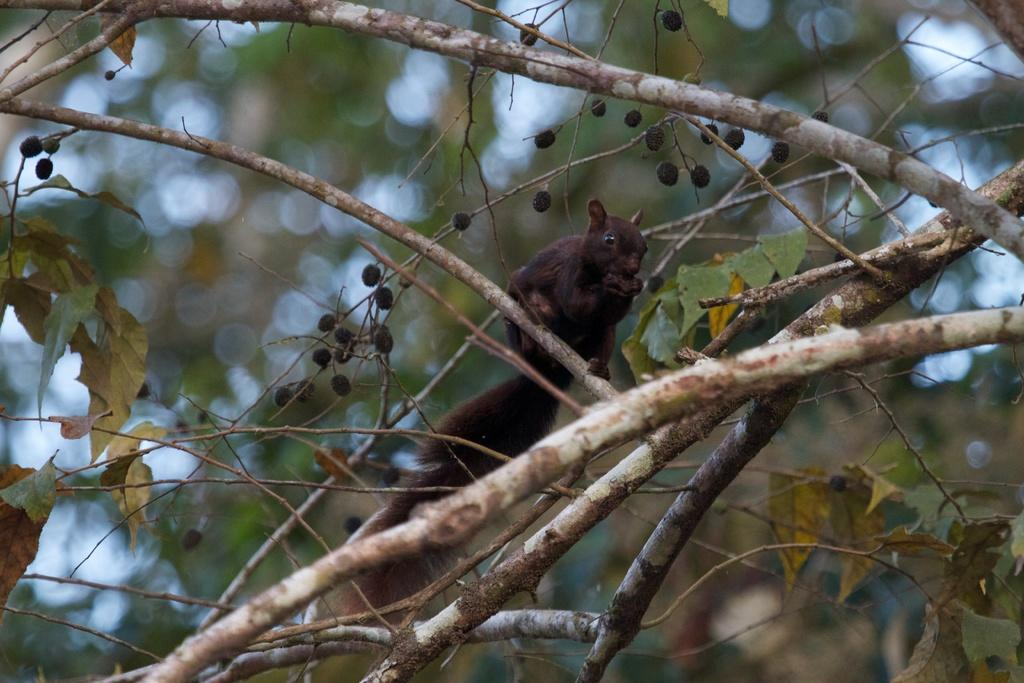What animal can be seen in the image? There is a squirrel in the image. Where is the squirrel located? The squirrel is on a tree branch. What can be seen in the background of the image? There are trees visible in the background of the image. How would you describe the background of the image? The background is blurry. How many ladybugs are sitting on the squirrel's tail in the image? There are no ladybugs present in the image, so it is not possible to determine how many might be sitting on the squirrel's tail. 